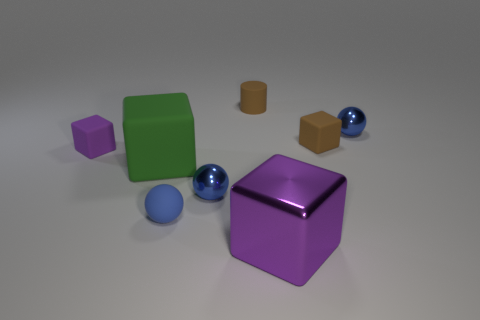Is there any other thing that has the same color as the rubber sphere?
Make the answer very short. Yes. How many matte things are brown cylinders or large cubes?
Your response must be concise. 2. What is the material of the small object that is behind the small blue thing to the right of the big purple object that is in front of the small rubber cylinder?
Keep it short and to the point. Rubber. What material is the purple block that is behind the large object that is to the left of the large purple shiny object?
Ensure brevity in your answer.  Rubber. Do the purple thing on the right side of the small blue rubber sphere and the green rubber object that is to the left of the tiny brown matte cube have the same size?
Provide a short and direct response. Yes. How many large objects are either gray rubber balls or rubber blocks?
Your response must be concise. 1. What number of things are either brown matte things on the right side of the purple metallic thing or gray balls?
Offer a terse response. 1. What number of other things are the same shape as the large green object?
Provide a short and direct response. 3. How many brown things are either shiny balls or metallic things?
Offer a terse response. 0. The small ball that is the same material as the small cylinder is what color?
Keep it short and to the point. Blue. 